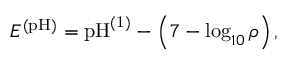<formula> <loc_0><loc_0><loc_500><loc_500>E ^ { ( p H ) } = p H ^ { ( 1 ) } - \left ( 7 - \log _ { 1 0 } { \rho } \right ) ,</formula> 